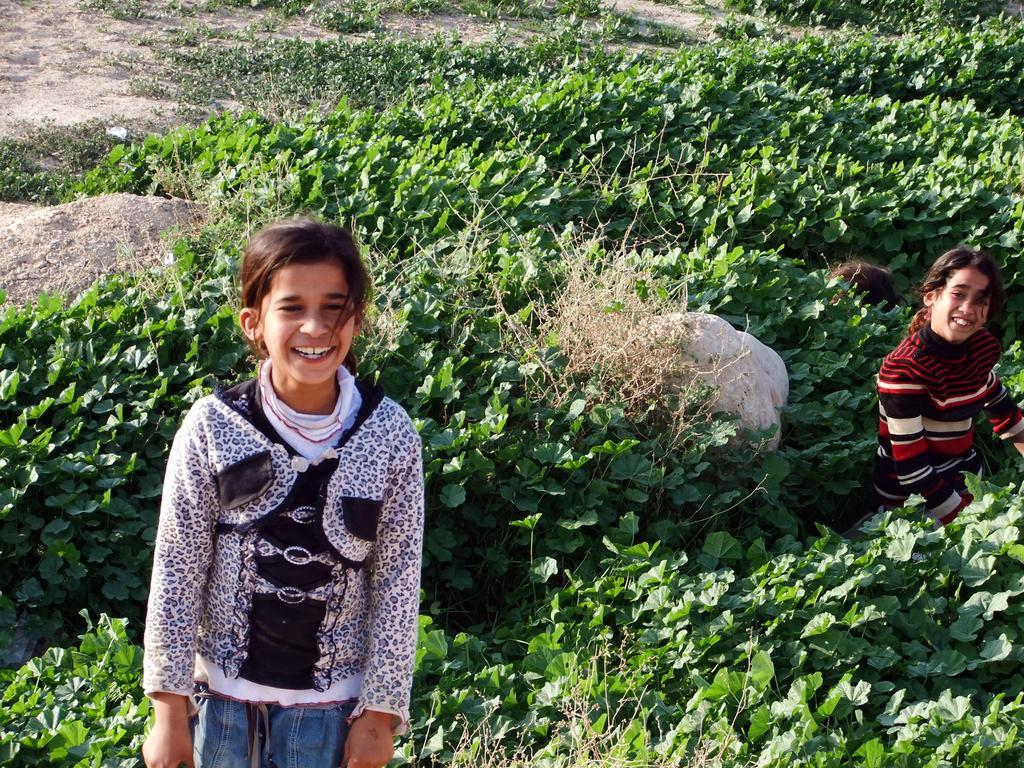Can you describe this image briefly? In this image we can see children standing between the plants. In the background there are rocks, plants and ground. 